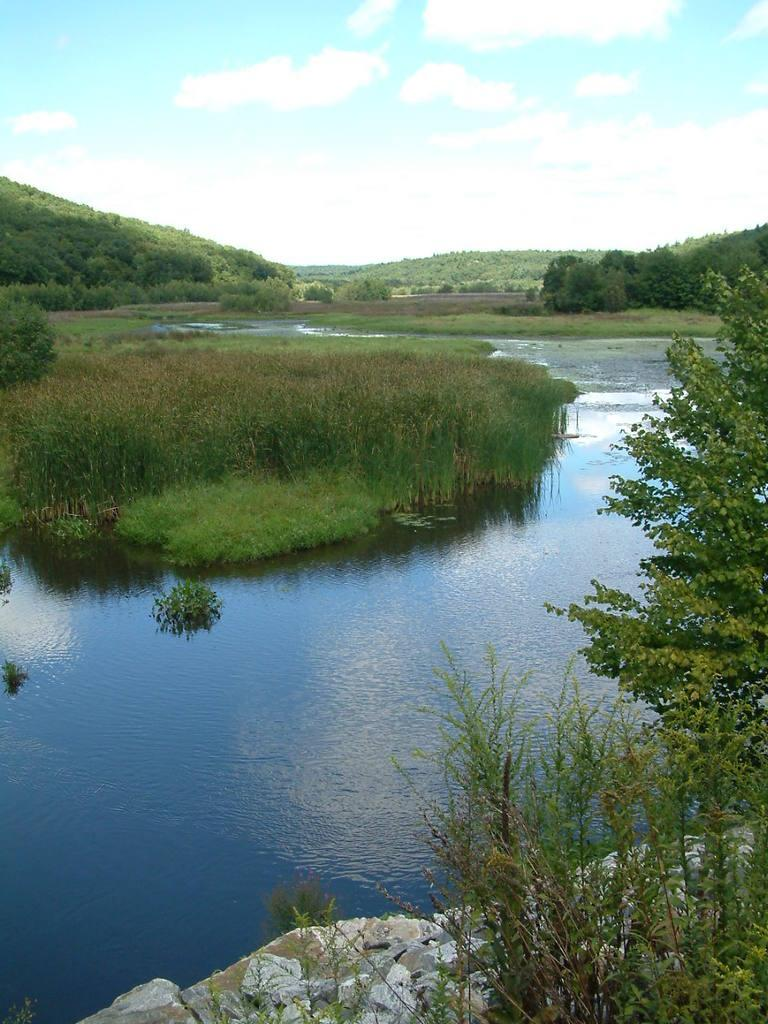What type of vegetation can be seen in the image? There are plants, grass, and trees visible in the image. What natural element can be seen in the image? Water is visible in the image. What type of terrain is present in the image? There are stones and hills visible in the image. What is visible in the sky in the image? The sky is visible in the image, and there are clouds present. What type of meal is being prepared on the plant in the image? There is no meal being prepared in the image, as it features natural elements like plants, grass, trees, water, stones, hills, and clouds. 